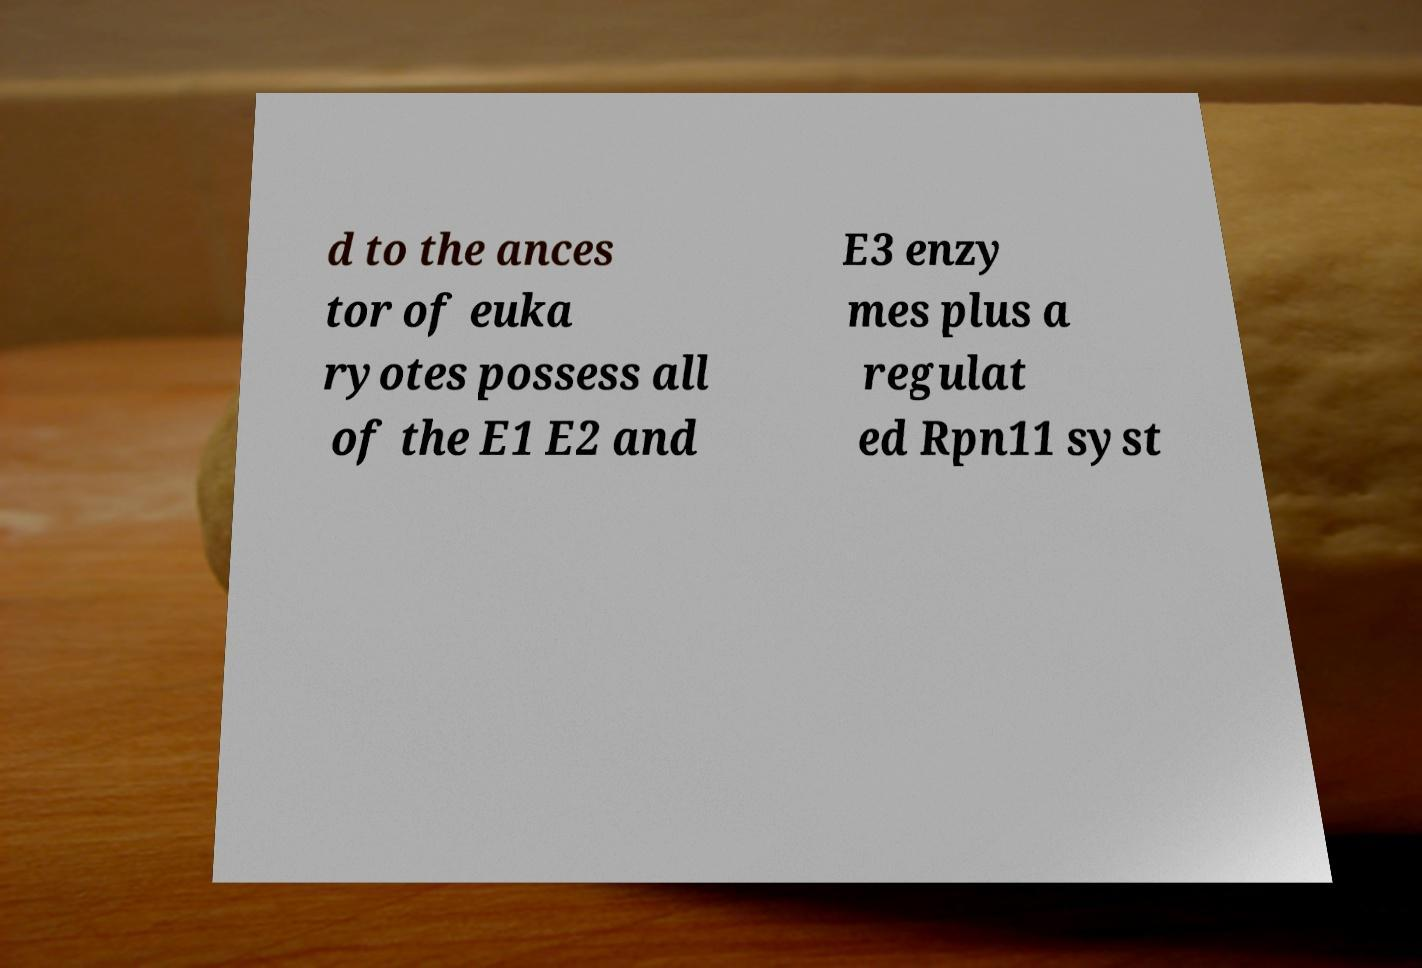Could you extract and type out the text from this image? d to the ances tor of euka ryotes possess all of the E1 E2 and E3 enzy mes plus a regulat ed Rpn11 syst 